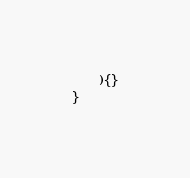<code> <loc_0><loc_0><loc_500><loc_500><_TypeScript_>	){}
}</code> 